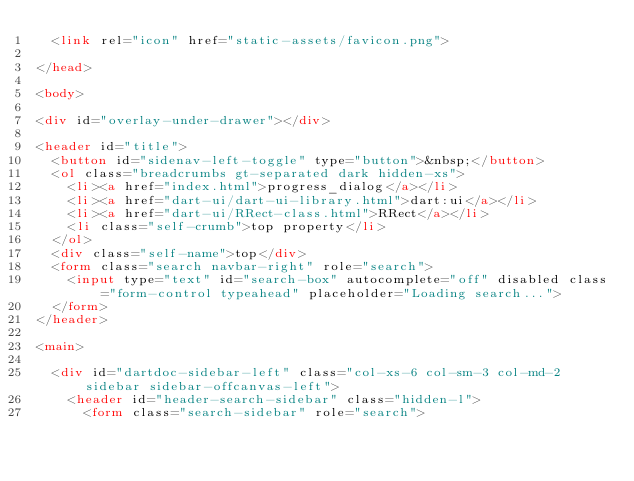Convert code to text. <code><loc_0><loc_0><loc_500><loc_500><_HTML_>  <link rel="icon" href="static-assets/favicon.png">
  
</head>

<body>

<div id="overlay-under-drawer"></div>

<header id="title">
  <button id="sidenav-left-toggle" type="button">&nbsp;</button>
  <ol class="breadcrumbs gt-separated dark hidden-xs">
    <li><a href="index.html">progress_dialog</a></li>
    <li><a href="dart-ui/dart-ui-library.html">dart:ui</a></li>
    <li><a href="dart-ui/RRect-class.html">RRect</a></li>
    <li class="self-crumb">top property</li>
  </ol>
  <div class="self-name">top</div>
  <form class="search navbar-right" role="search">
    <input type="text" id="search-box" autocomplete="off" disabled class="form-control typeahead" placeholder="Loading search...">
  </form>
</header>

<main>

  <div id="dartdoc-sidebar-left" class="col-xs-6 col-sm-3 col-md-2 sidebar sidebar-offcanvas-left">
    <header id="header-search-sidebar" class="hidden-l">
      <form class="search-sidebar" role="search"></code> 